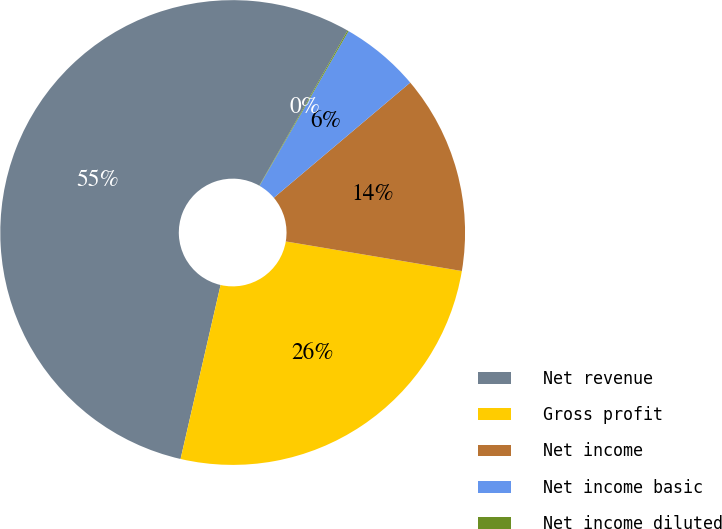Convert chart to OTSL. <chart><loc_0><loc_0><loc_500><loc_500><pie_chart><fcel>Net revenue<fcel>Gross profit<fcel>Net income<fcel>Net income basic<fcel>Net income diluted<nl><fcel>54.63%<fcel>25.95%<fcel>13.81%<fcel>5.53%<fcel>0.08%<nl></chart> 